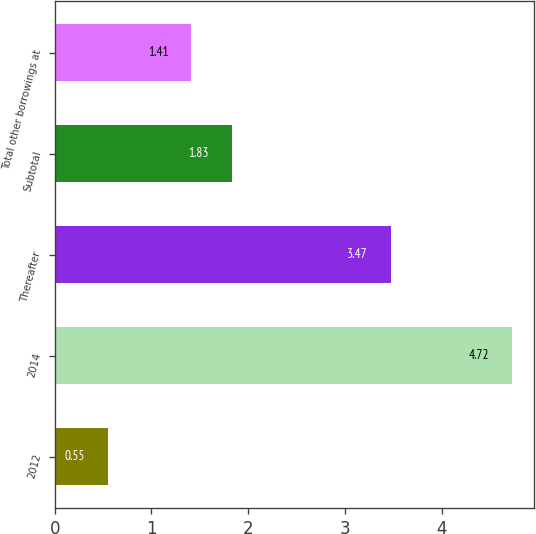Convert chart to OTSL. <chart><loc_0><loc_0><loc_500><loc_500><bar_chart><fcel>2012<fcel>2014<fcel>Thereafter<fcel>Subtotal<fcel>Total other borrowings at<nl><fcel>0.55<fcel>4.72<fcel>3.47<fcel>1.83<fcel>1.41<nl></chart> 